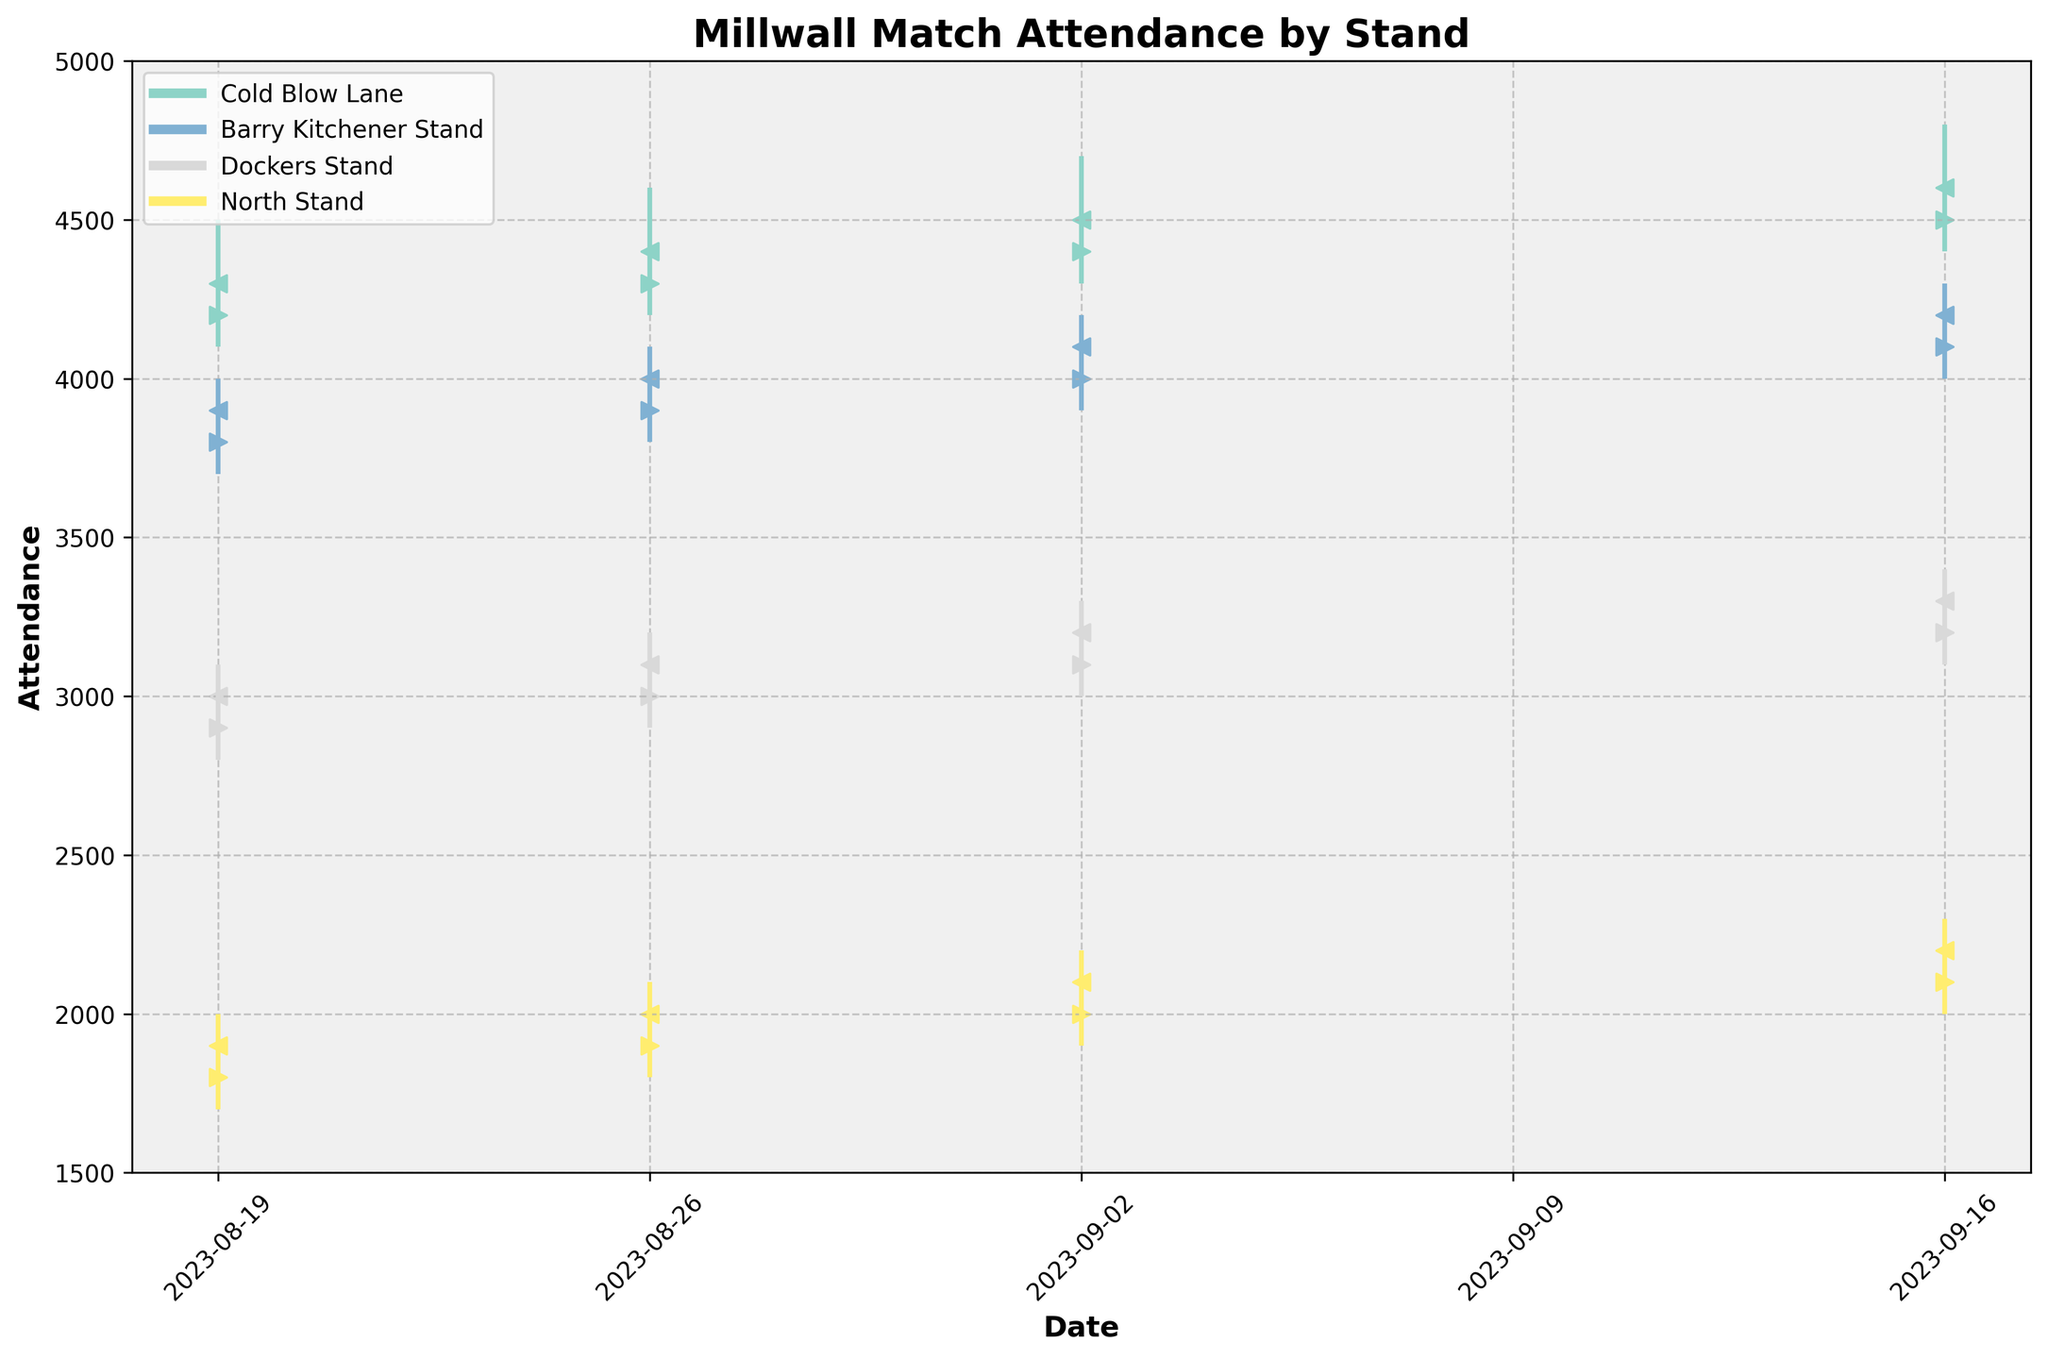What's the title of the chart? The title of the chart is located at the top and is clearly labeled. It's text-based and provides an overview of what the chart represents.
Answer: Millwall Match Attendance by Stand Which stand had the highest close value on 2023-09-02? To determine this, we look at the data points for each stand on 2023-09-02 and check the 'Close' values. Cold Blow Lane has a closing value of 4500 which is the highest.
Answer: Cold Blow Lane What is the trend of attendance for the Cold Blow Lane stand over the given dates? By observing the close values for the Cold Blow Lane stand from the plot, we can see the trend. The attendance is increasing week by week. The values are 4300, 4400, 4500, and 4600.
Answer: Increasing On which date did the Dockers Stand have the lowest low value, and what was that value? By examining the lows for each date in the Dockers Stand, the lowest value is 2800 on 2023-08-19.
Answer: 2023-08-19, 2800 What is the average closing attendance for the North Stand? Sum the close values for the North Stand across all dates and divide by the number of dates. For North Stand: (1900 + 2000 + 2100 + 2200)/4 = 2050.
Answer: 2050 How does the attendance in Cold Blow Lane compare to Barry Kitchener Stand on 2023-08-26 in terms of closing values? We need to look up the closing values for Cold Blow Lane and Barry Kitchener Stand on 2023-08-26. Cold Blow Lane has 4400, and Barry Kitchener has 4000. So, Cold Blow Lane has a higher attendance by 400.
Answer: Cold Blow Lane, higher What are the individual attendance volumes for the four stands on 2023-09-16? Check the volume data for each stand on 2023-09-16. The volumes are: Cold Blow Lane=4600, Barry Kitchener Stand=4200, Dockers Stand=3300, and North Stand=2200.
Answer: 4600, 4200, 3300, 2200 On what date did North Stand and Barry Kitchener Stand have the same closing value, and what was that value? By checking the closing values for both stands, we see that on 2023-08-19, both had the same closing value of 3900.
Answer: 2023-08-19, 3900 Which stand exhibited the most fluctuation in attendance values over the given period? We analyze the highs and lows for each stand and see which has the largest range or fluctuation. Cold Blow Lane has significant fluctuation compared to other stands because its range is notably wider.
Answer: Cold Blow Lane 